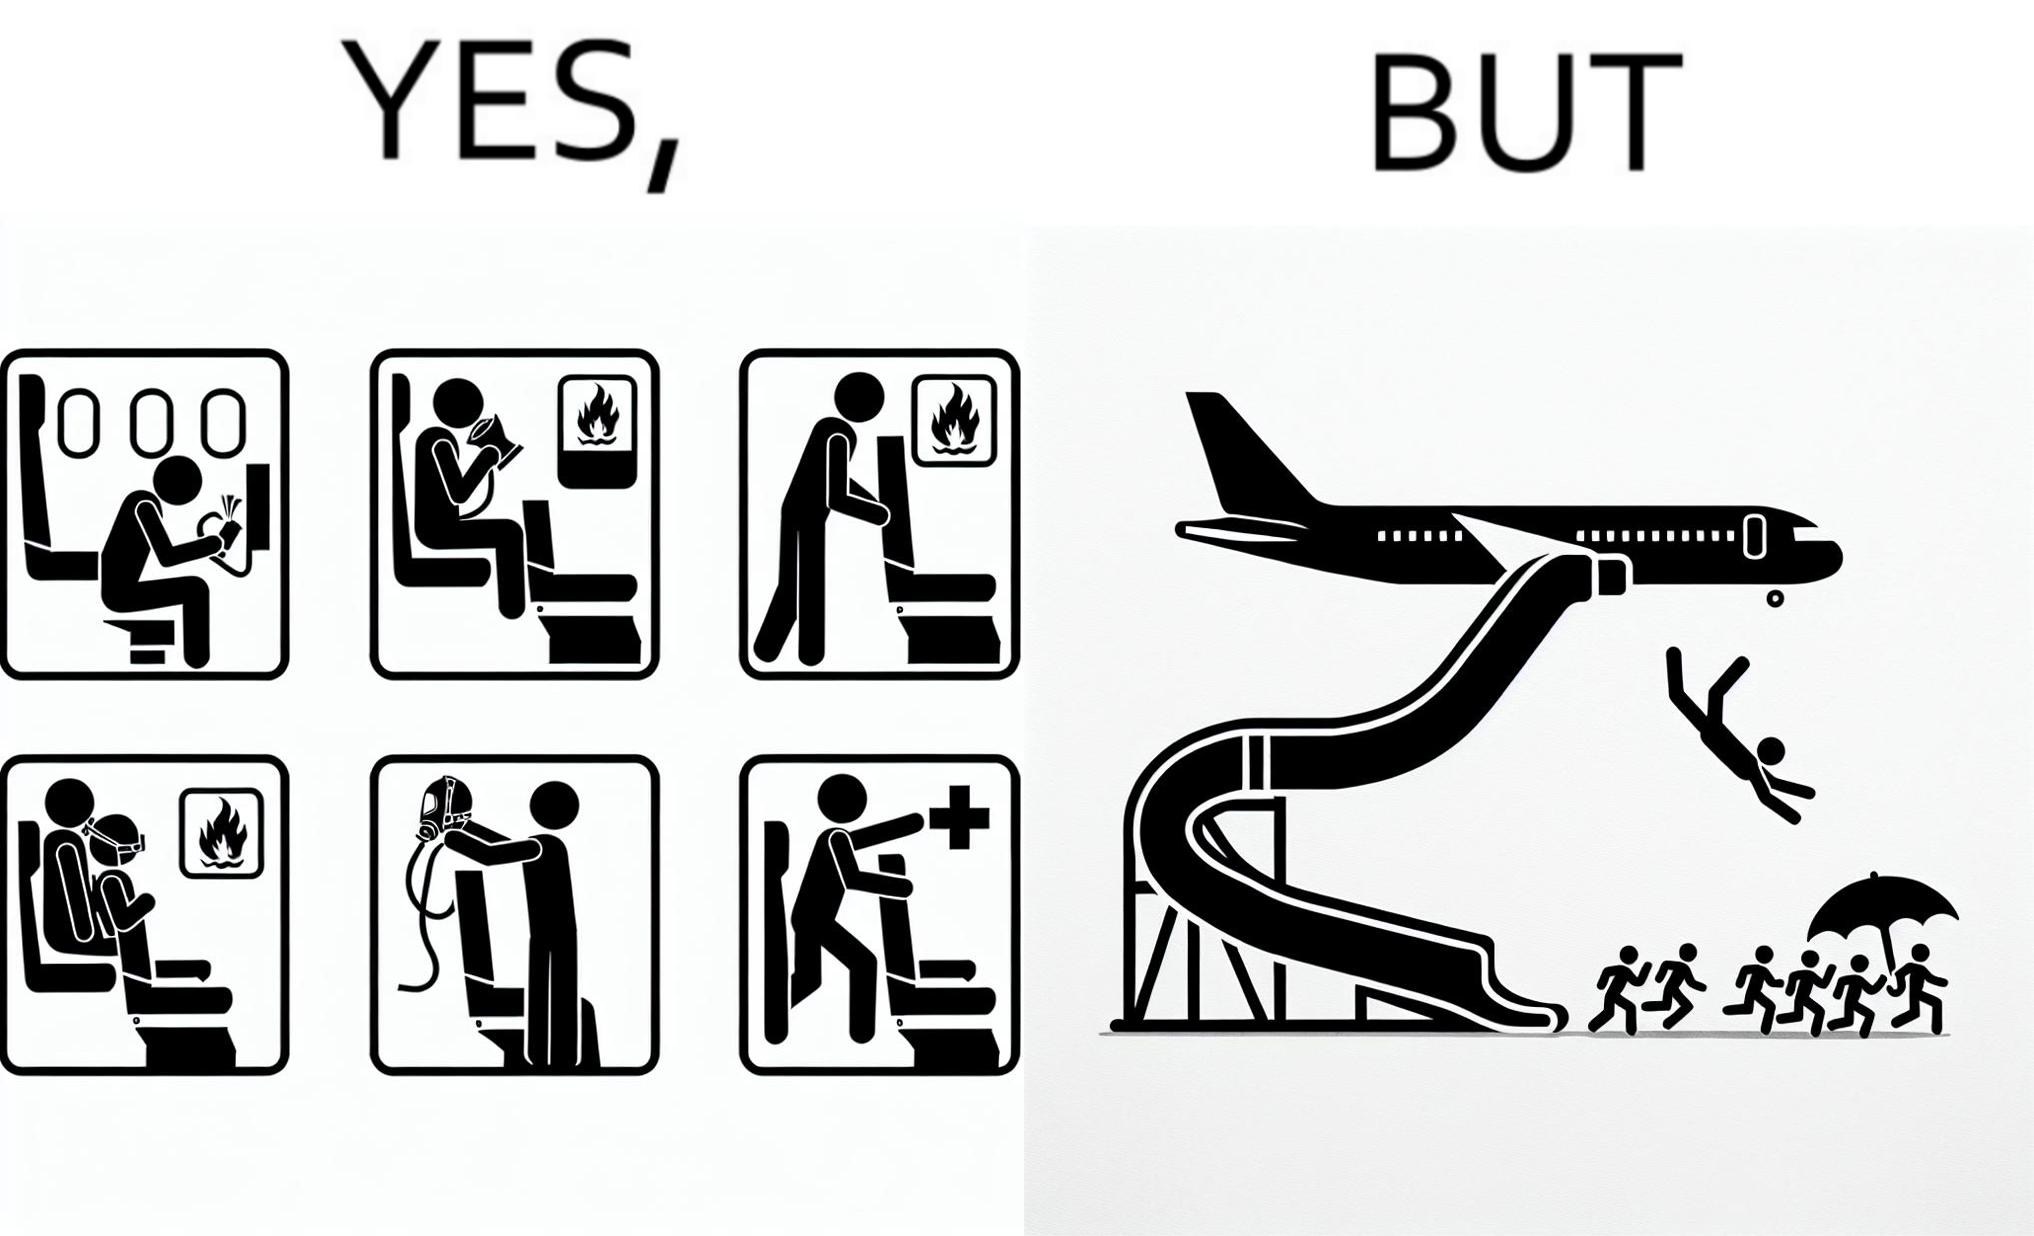Explain why this image is satirical. These images are funny since it shows how we are taught emergency procedures to follow in case of an accident while in an airplane but how none of them work if the plane is still in air 